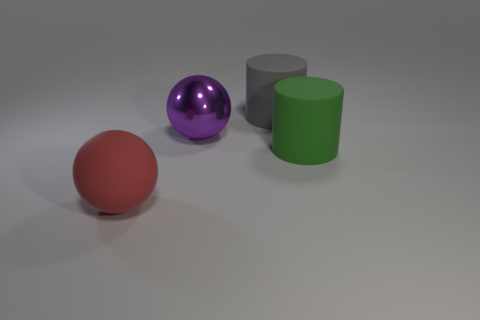Add 3 big cyan shiny cubes. How many objects exist? 7 Add 1 big red spheres. How many big red spheres exist? 2 Subtract 0 gray blocks. How many objects are left? 4 Subtract all large matte spheres. Subtract all big green matte things. How many objects are left? 2 Add 3 red matte spheres. How many red matte spheres are left? 4 